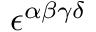<formula> <loc_0><loc_0><loc_500><loc_500>\epsilon ^ { \alpha \beta \gamma \delta }</formula> 